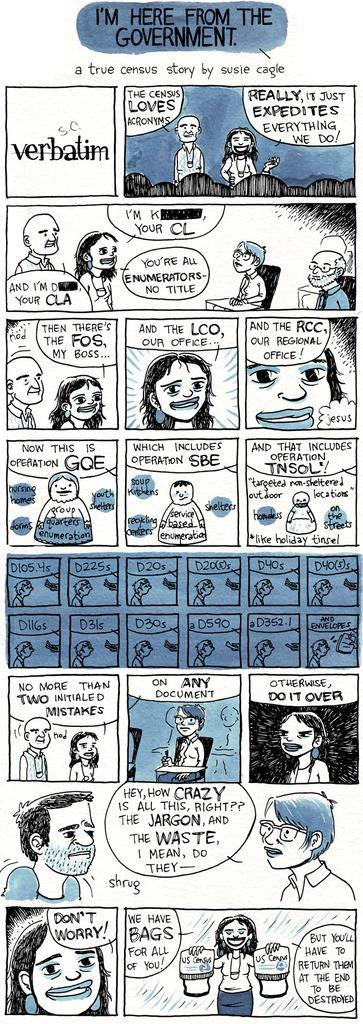What type of images are present in the picture? There are cartoon images of people in the image. What else can be seen in the cartoon images besides the people? There are other things depicted in the cartoon images. Is there any text or writing on the image? Yes, there is something written on the image. How many times did the person attempt to open the cork in the image? There is no cork present in the image, so it is not possible to determine how many times someone attempted to open it. 